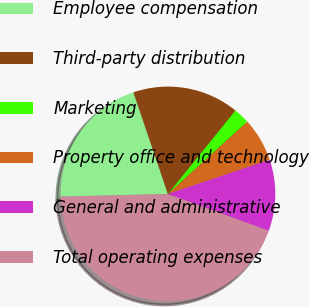Convert chart. <chart><loc_0><loc_0><loc_500><loc_500><pie_chart><fcel>Employee compensation<fcel>Third-party distribution<fcel>Marketing<fcel>Property office and technology<fcel>General and administrative<fcel>Total operating expenses<nl><fcel>20.19%<fcel>16.03%<fcel>2.42%<fcel>6.58%<fcel>10.74%<fcel>44.03%<nl></chart> 